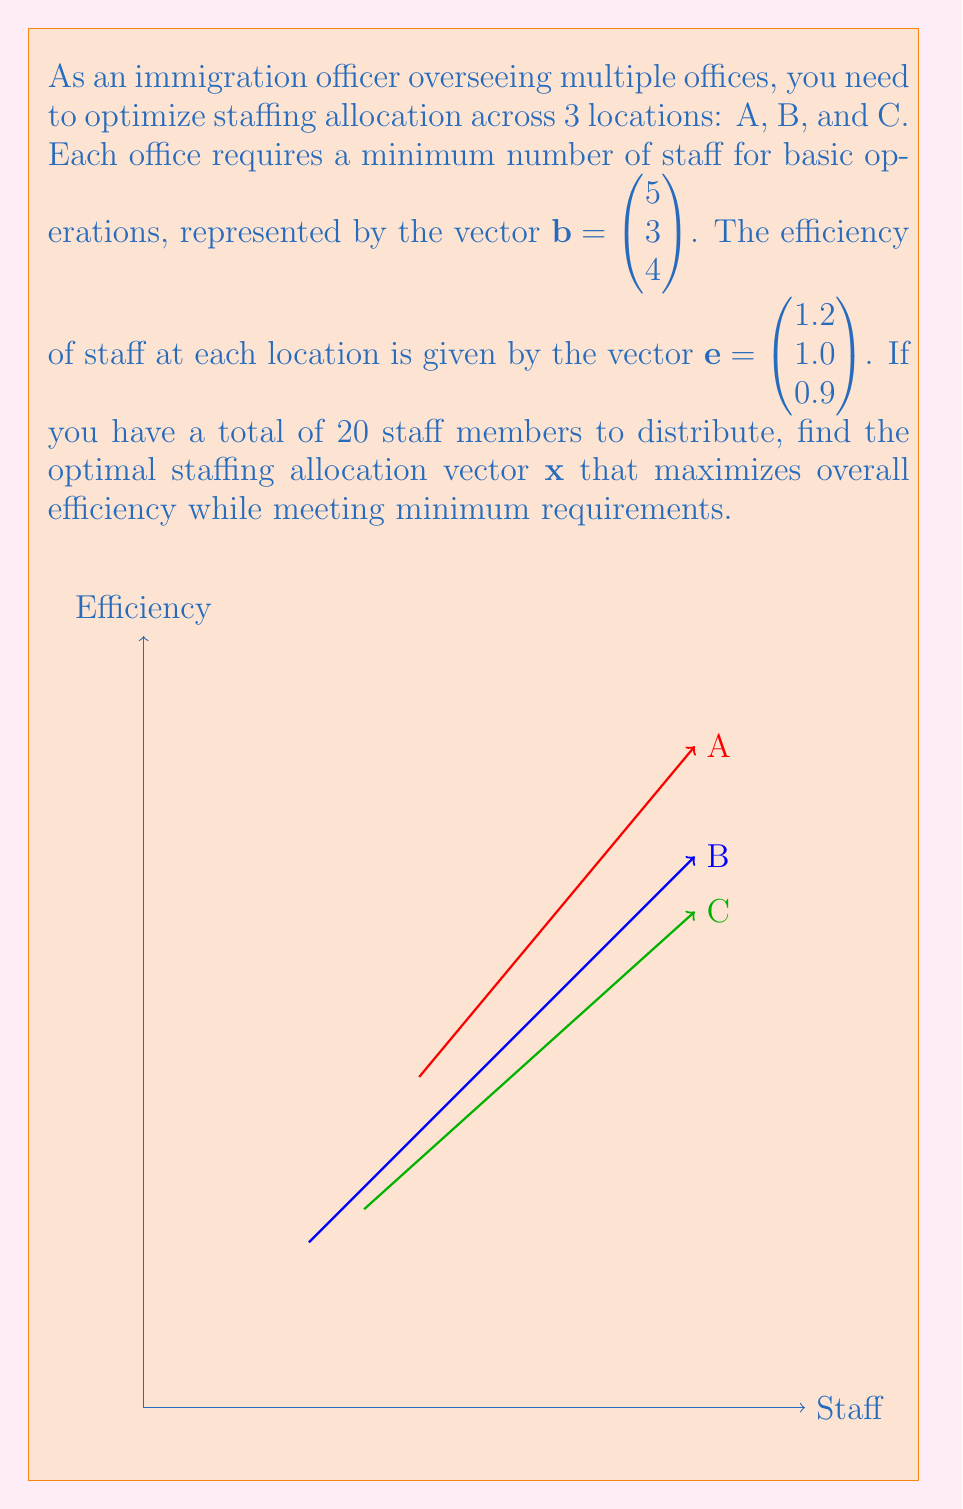Teach me how to tackle this problem. Let's approach this step-by-step:

1) We need to maximize the dot product of the efficiency vector and the staffing vector:
   $f(\mathbf{x}) = \mathbf{e} \cdot \mathbf{x} = 1.2x_1 + 1.0x_2 + 0.9x_3$

2) Subject to the constraints:
   a) $x_1 + x_2 + x_3 = 20$ (total staff)
   b) $x_1 \geq 5, x_2 \geq 3, x_3 \geq 4$ (minimum requirements)

3) Given the efficiency values, we should allocate as many staff as possible to office A, then B, then C.

4) Start by meeting minimum requirements:
   $x_1 = 5, x_2 = 3, x_3 = 4$
   Total so far: 12 staff

5) Remaining 8 staff should be allocated to A first:
   $x_1 = 5 + 8 = 13, x_2 = 3, x_3 = 4$

6) Therefore, the optimal staffing vector is:
   $\mathbf{x} = \begin{pmatrix} 13 \\ 3 \\ 4 \end{pmatrix}$

7) We can verify that this satisfies all constraints:
   - Total staff: $13 + 3 + 4 = 20$
   - Meets or exceeds minimum requirements at each office

8) The maximum efficiency achieved is:
   $f(\mathbf{x}) = 1.2(13) + 1.0(3) + 0.9(4) = 15.6 + 3 + 3.6 = 22.2$
Answer: $\mathbf{x} = \begin{pmatrix} 13 \\ 3 \\ 4 \end{pmatrix}$ 